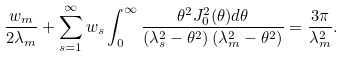Convert formula to latex. <formula><loc_0><loc_0><loc_500><loc_500>\frac { w _ { m } } { 2 \lambda _ { m } } + \sum _ { s = 1 } ^ { \infty } w _ { s } \int _ { 0 } ^ { \infty } \frac { \theta ^ { 2 } J _ { 0 } ^ { 2 } ( \theta ) d \theta } { \left ( \lambda _ { s } ^ { 2 } - \theta ^ { 2 } \right ) \left ( \lambda _ { m } ^ { 2 } - \theta ^ { 2 } \right ) } = \frac { 3 \pi } { \lambda _ { m } ^ { 2 } } .</formula> 